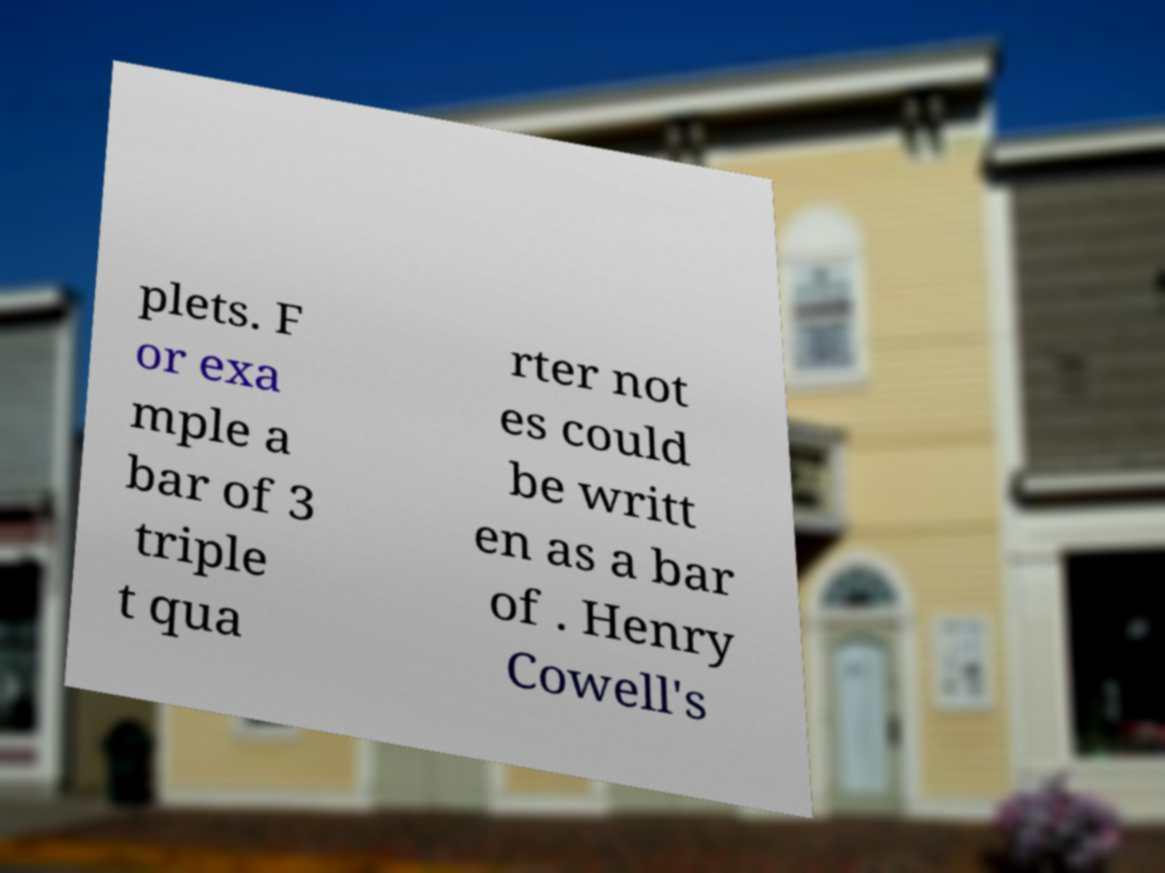What messages or text are displayed in this image? I need them in a readable, typed format. plets. F or exa mple a bar of 3 triple t qua rter not es could be writt en as a bar of . Henry Cowell's 